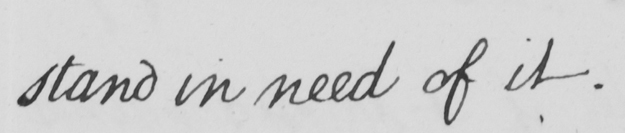Please transcribe the handwritten text in this image. stand in need of it . 